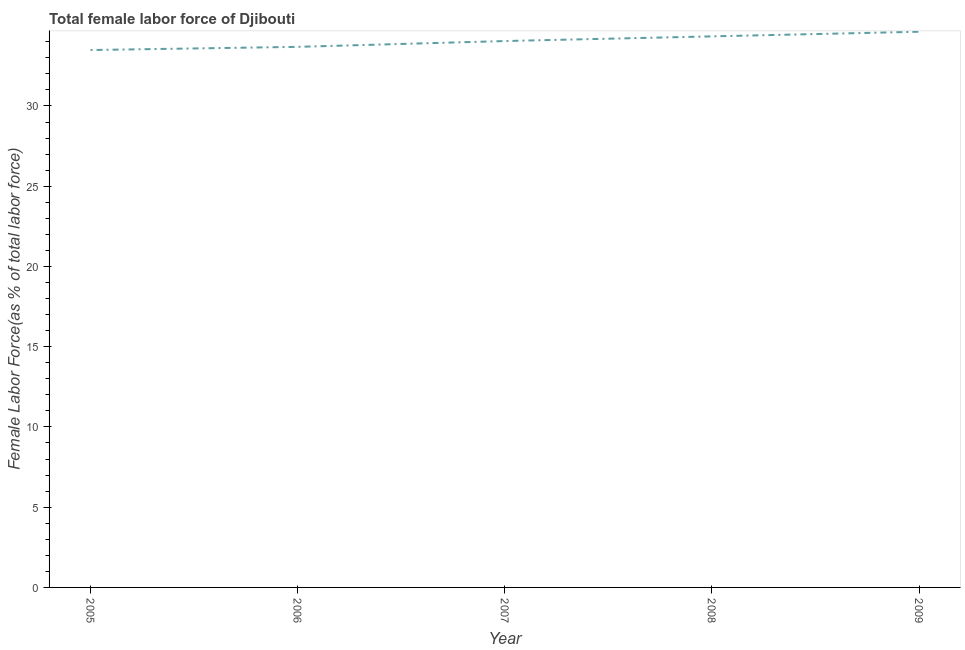What is the total female labor force in 2005?
Ensure brevity in your answer.  33.49. Across all years, what is the maximum total female labor force?
Your answer should be very brief. 34.63. Across all years, what is the minimum total female labor force?
Provide a short and direct response. 33.49. What is the sum of the total female labor force?
Keep it short and to the point. 170.19. What is the difference between the total female labor force in 2005 and 2009?
Your response must be concise. -1.14. What is the average total female labor force per year?
Offer a very short reply. 34.04. What is the median total female labor force?
Offer a very short reply. 34.05. What is the ratio of the total female labor force in 2005 to that in 2008?
Ensure brevity in your answer.  0.98. Is the total female labor force in 2008 less than that in 2009?
Keep it short and to the point. Yes. What is the difference between the highest and the second highest total female labor force?
Provide a succinct answer. 0.29. Is the sum of the total female labor force in 2005 and 2008 greater than the maximum total female labor force across all years?
Keep it short and to the point. Yes. What is the difference between the highest and the lowest total female labor force?
Offer a very short reply. 1.14. Does the total female labor force monotonically increase over the years?
Make the answer very short. Yes. How many lines are there?
Provide a short and direct response. 1. Are the values on the major ticks of Y-axis written in scientific E-notation?
Your answer should be very brief. No. What is the title of the graph?
Your answer should be compact. Total female labor force of Djibouti. What is the label or title of the X-axis?
Provide a short and direct response. Year. What is the label or title of the Y-axis?
Give a very brief answer. Female Labor Force(as % of total labor force). What is the Female Labor Force(as % of total labor force) of 2005?
Your response must be concise. 33.49. What is the Female Labor Force(as % of total labor force) of 2006?
Your response must be concise. 33.69. What is the Female Labor Force(as % of total labor force) of 2007?
Make the answer very short. 34.05. What is the Female Labor Force(as % of total labor force) in 2008?
Your response must be concise. 34.34. What is the Female Labor Force(as % of total labor force) in 2009?
Your answer should be compact. 34.63. What is the difference between the Female Labor Force(as % of total labor force) in 2005 and 2006?
Your response must be concise. -0.2. What is the difference between the Female Labor Force(as % of total labor force) in 2005 and 2007?
Ensure brevity in your answer.  -0.56. What is the difference between the Female Labor Force(as % of total labor force) in 2005 and 2008?
Provide a succinct answer. -0.85. What is the difference between the Female Labor Force(as % of total labor force) in 2005 and 2009?
Make the answer very short. -1.14. What is the difference between the Female Labor Force(as % of total labor force) in 2006 and 2007?
Offer a terse response. -0.36. What is the difference between the Female Labor Force(as % of total labor force) in 2006 and 2008?
Your answer should be very brief. -0.65. What is the difference between the Female Labor Force(as % of total labor force) in 2006 and 2009?
Make the answer very short. -0.94. What is the difference between the Female Labor Force(as % of total labor force) in 2007 and 2008?
Provide a succinct answer. -0.29. What is the difference between the Female Labor Force(as % of total labor force) in 2007 and 2009?
Offer a very short reply. -0.58. What is the difference between the Female Labor Force(as % of total labor force) in 2008 and 2009?
Offer a terse response. -0.29. What is the ratio of the Female Labor Force(as % of total labor force) in 2005 to that in 2006?
Offer a terse response. 0.99. What is the ratio of the Female Labor Force(as % of total labor force) in 2005 to that in 2009?
Make the answer very short. 0.97. What is the ratio of the Female Labor Force(as % of total labor force) in 2006 to that in 2007?
Offer a very short reply. 0.99. What is the ratio of the Female Labor Force(as % of total labor force) in 2006 to that in 2008?
Keep it short and to the point. 0.98. What is the ratio of the Female Labor Force(as % of total labor force) in 2006 to that in 2009?
Your answer should be compact. 0.97. What is the ratio of the Female Labor Force(as % of total labor force) in 2007 to that in 2008?
Offer a terse response. 0.99. What is the ratio of the Female Labor Force(as % of total labor force) in 2007 to that in 2009?
Give a very brief answer. 0.98. 